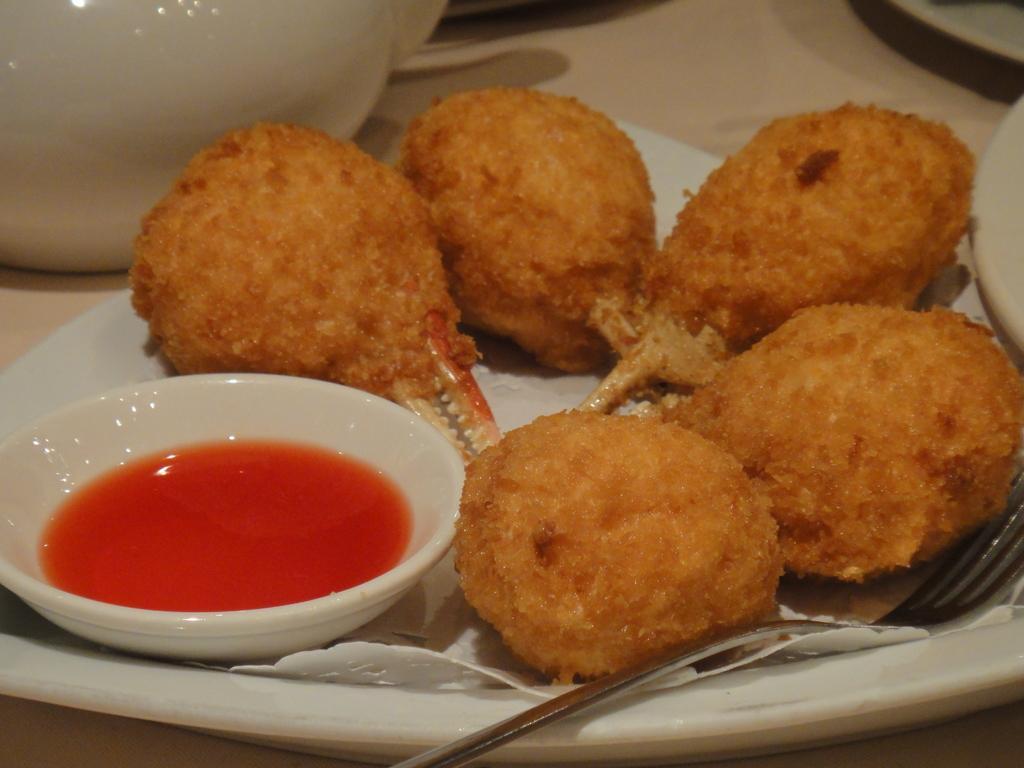In one or two sentences, can you explain what this image depicts? In the picture I can see some food items, a bowl with sauce and fork are placed on the white color plate and also we can see a few more objects are also placed on the surface. 